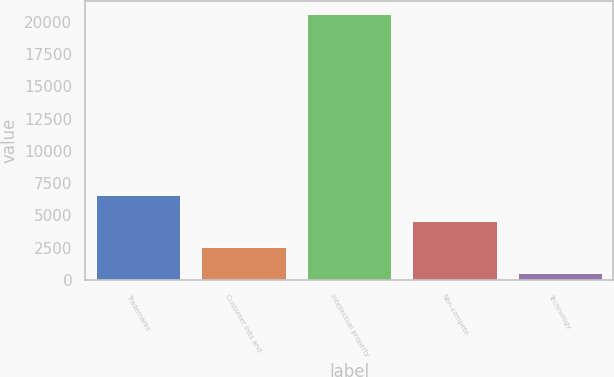<chart> <loc_0><loc_0><loc_500><loc_500><bar_chart><fcel>Trademarks<fcel>Customer lists and<fcel>Intellectual property<fcel>Non-compete<fcel>Technology<nl><fcel>6547.2<fcel>2544.4<fcel>20557<fcel>4545.8<fcel>543<nl></chart> 